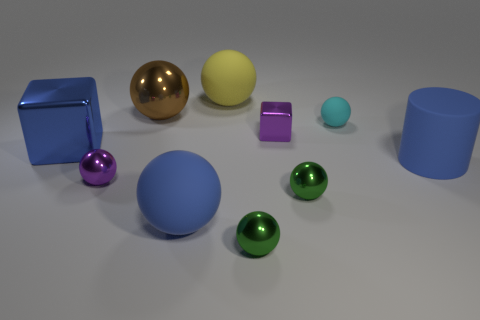Is the number of small cyan balls that are behind the large shiny ball the same as the number of brown things?
Make the answer very short. No. What number of other yellow spheres are made of the same material as the large yellow sphere?
Ensure brevity in your answer.  0. There is a tiny ball that is made of the same material as the yellow thing; what color is it?
Your answer should be very brief. Cyan. Is the size of the yellow object the same as the metal block to the right of the large blue shiny thing?
Your response must be concise. No. What is the shape of the large brown metal object?
Your answer should be very brief. Sphere. How many large matte objects have the same color as the large rubber cylinder?
Your answer should be very brief. 1. There is another small metal object that is the same shape as the blue shiny object; what color is it?
Your answer should be very brief. Purple. There is a metal cube on the right side of the blue metallic block; how many big blue cylinders are behind it?
Provide a short and direct response. 0. What number of balls are tiny rubber objects or large metallic things?
Your answer should be very brief. 2. Are there any big cubes?
Your answer should be compact. Yes. 